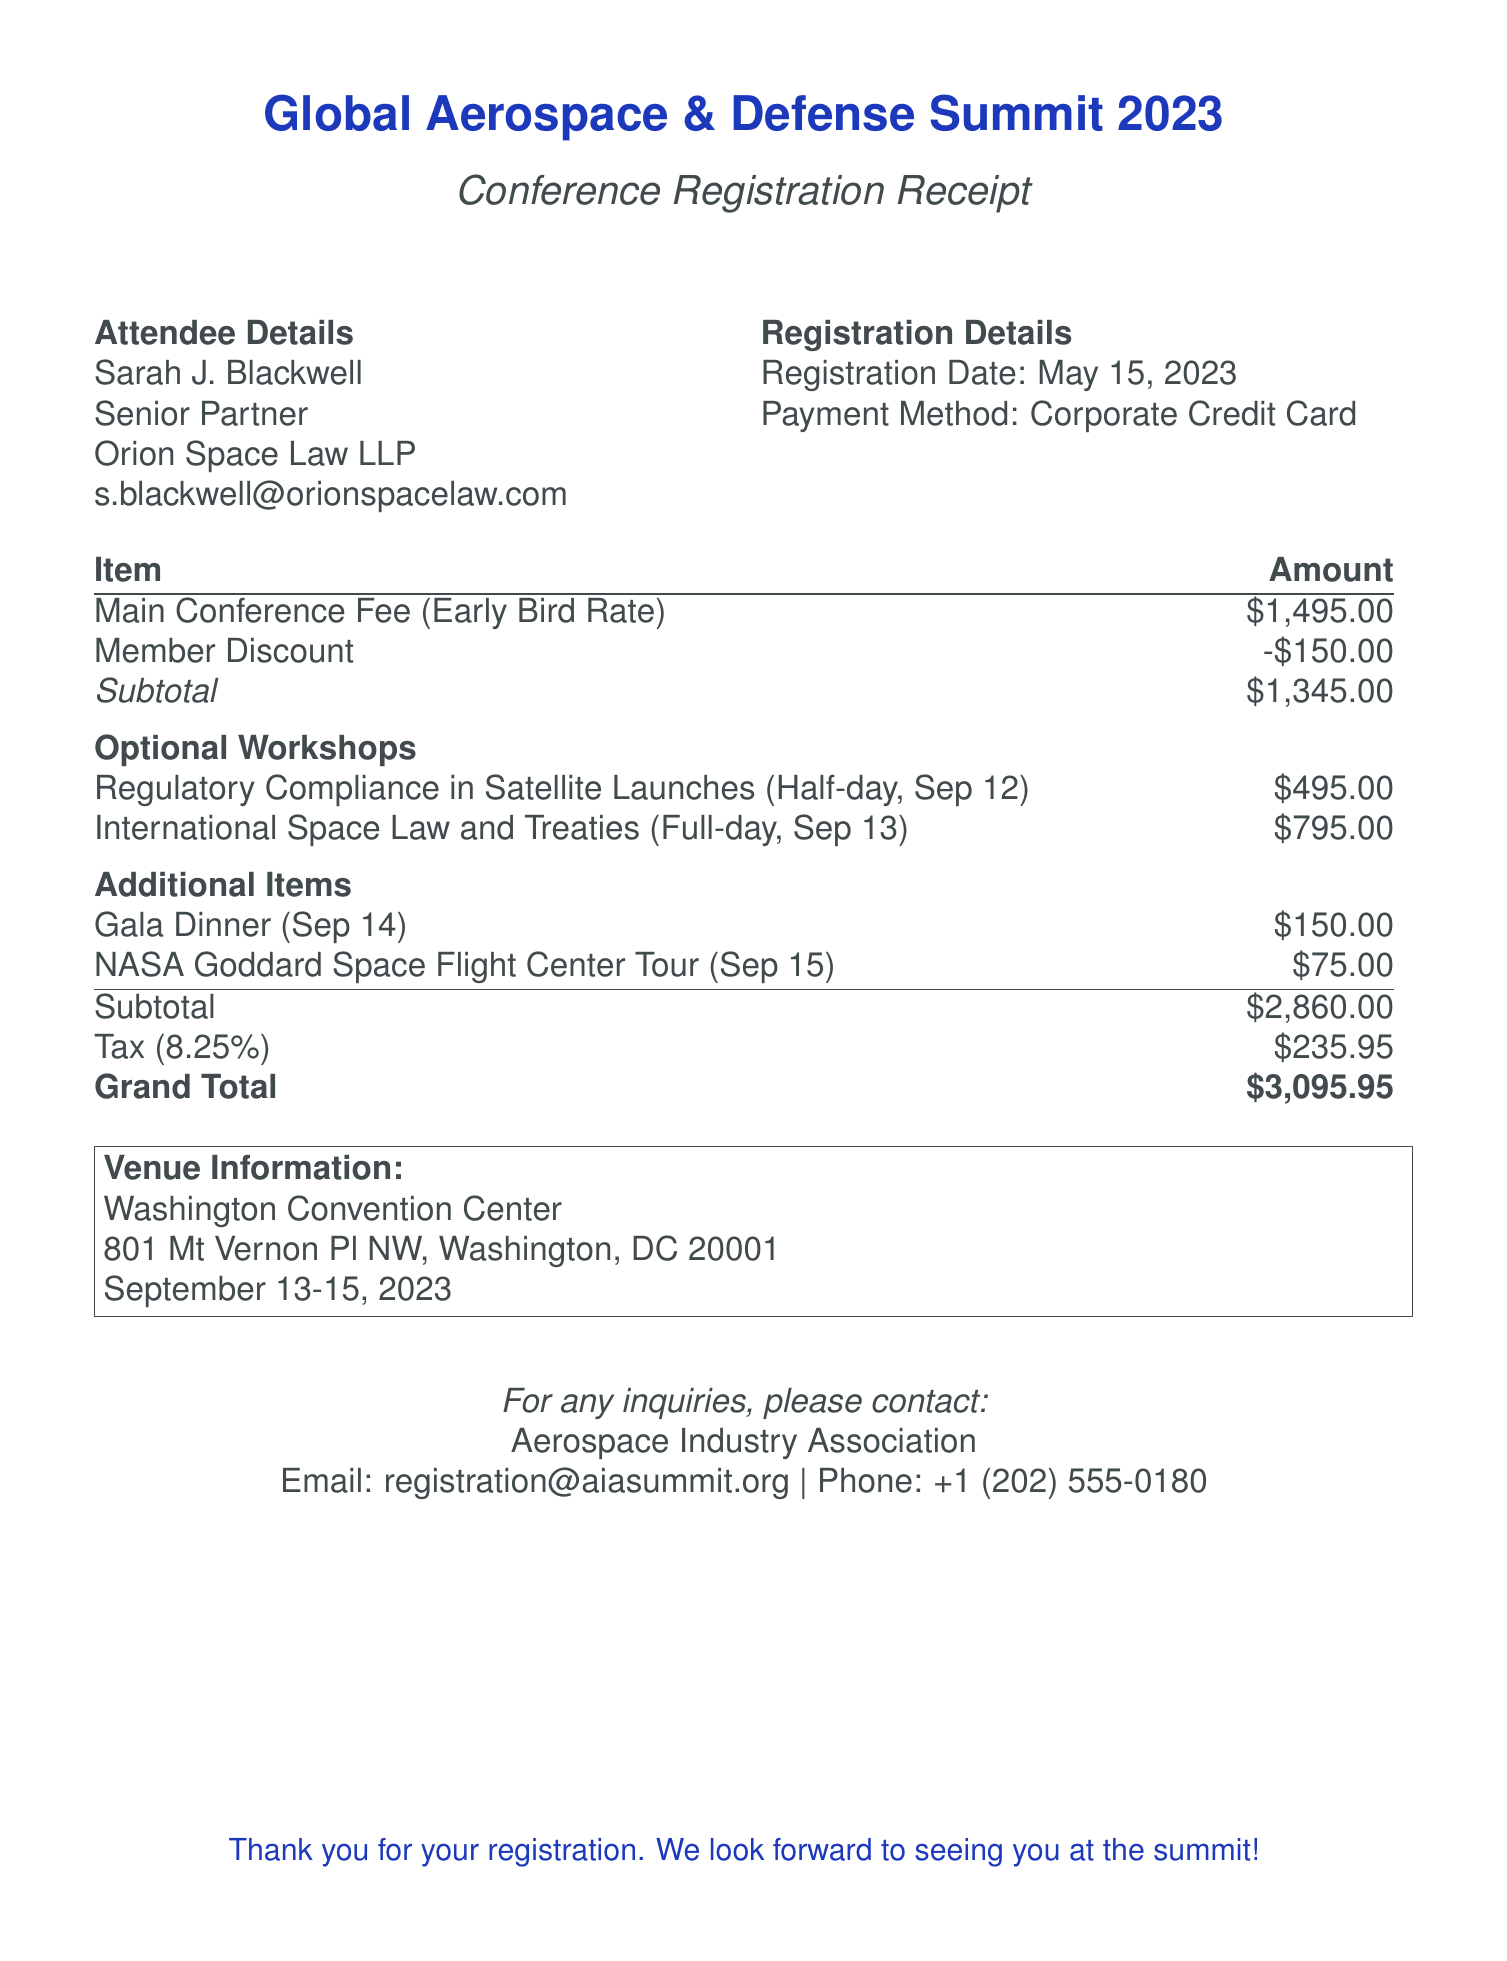What is the name of the attendee? The attendee's name is listed in the document under Attendee Details.
Answer: Sarah J. Blackwell What is the registration number? The registration number is indicated prominently in the document.
Answer: GADS2023-1284 What is the total amount of tax charged? The total tax is detailed in the cost section of the document.
Answer: $235.95 What is the date of the Gala Dinner? The date for the Gala Dinner is mentioned in the Additional Items section.
Answer: September 14, 2023 What is the fee for the regulatory compliance workshop? The fee for this specific workshop is provided in the Optional Workshops section.
Answer: $495.00 What is the total cost after tax? The grand total reflects the overall cost after adding tax to the subtotal as shown in the document.
Answer: $3,095.95 What organization is hosting the conference? The name of the organizing entity is stated in the organizer details.
Answer: Aerospace Industry Association How many optional workshops were registered for? The number of workshops listed indicates how many were opted for in the registration.
Answer: Two What is the venue of the conference? The venue is mentioned clearly in the Venue Information section.
Answer: Washington Convention Center 